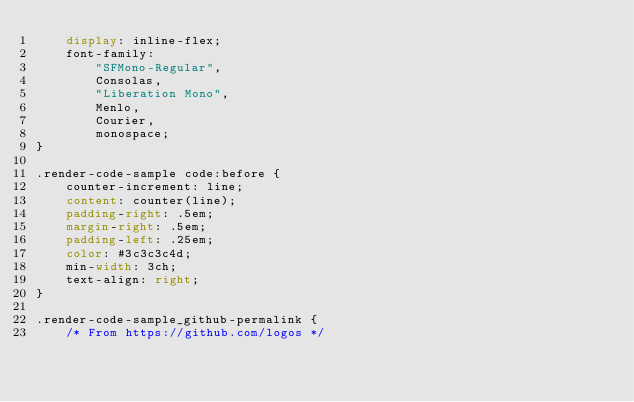<code> <loc_0><loc_0><loc_500><loc_500><_CSS_>    display: inline-flex;
    font-family:
        "SFMono-Regular",
        Consolas,
        "Liberation Mono",
        Menlo,
        Courier,
        monospace;
}

.render-code-sample code:before {
    counter-increment: line;
    content: counter(line);
    padding-right: .5em;
    margin-right: .5em;
    padding-left: .25em;
    color: #3c3c3c4d;
    min-width: 3ch;
    text-align: right;
}

.render-code-sample_github-permalink {
    /* From https://github.com/logos */</code> 